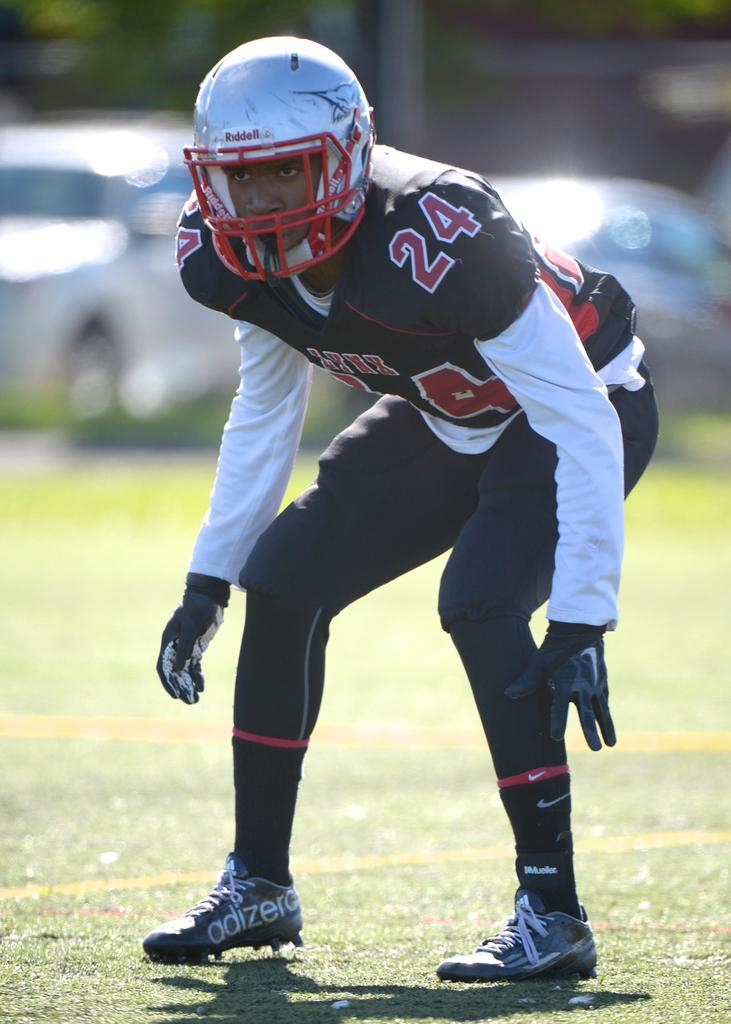What type of person can be seen in the image? There is a sportsman in the image. What is the sportsman doing in the image? The sportsman is standing on the ground and is in a squatting position. What protective gear is the sportsman wearing? The sportsman is wearing a helmet. How is the background of the image depicted? The background of the sportsman is blurred. What type of bears can be seen in the image? There are no bears present in the image; it features a sportsman. How many cattle are visible in the image? There are no cattle present in the image. 